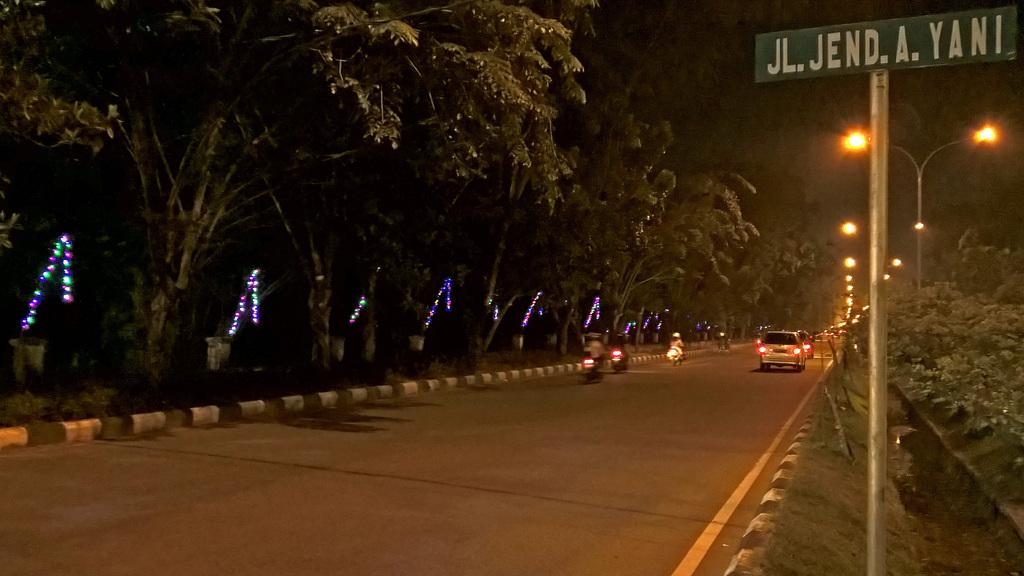What can be seen on the road in the image? There are vehicles on the road in the image. What is visible in the background of the image? There are trees, lights, and poles in the background of the image. Can you describe the board visible in the image? Yes, there is a board visible in the image. How many people are kissing in the image? There is no indication of any kissing in the image. What type of pollution can be seen in the image? There is no pollution visible in the image. 